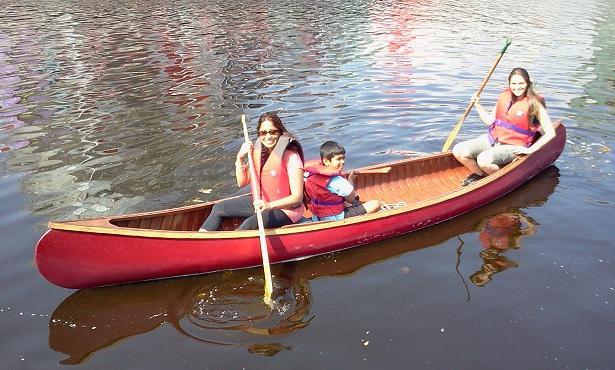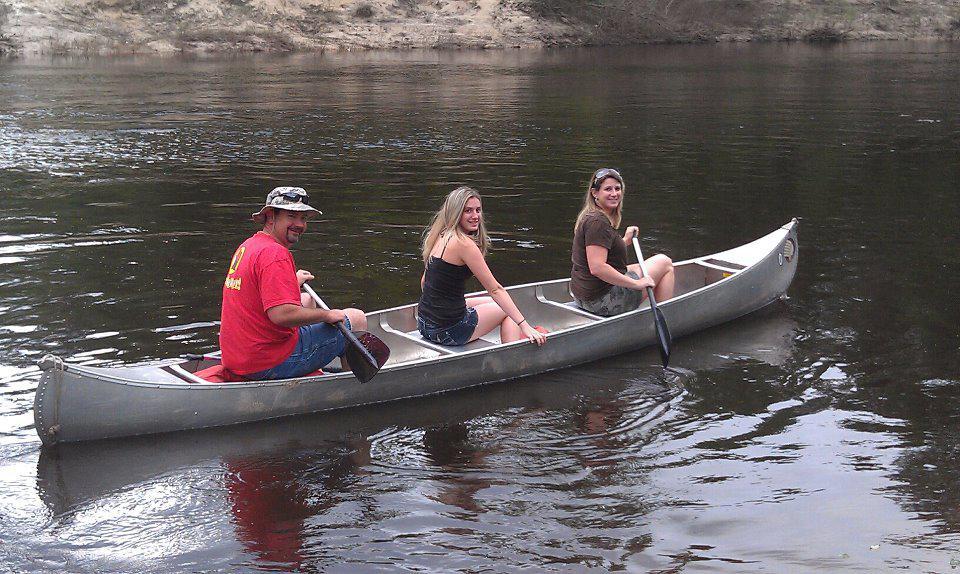The first image is the image on the left, the second image is the image on the right. For the images shown, is this caption "There is a child sitting between 2 adults in one of the images." true? Answer yes or no. Yes. 